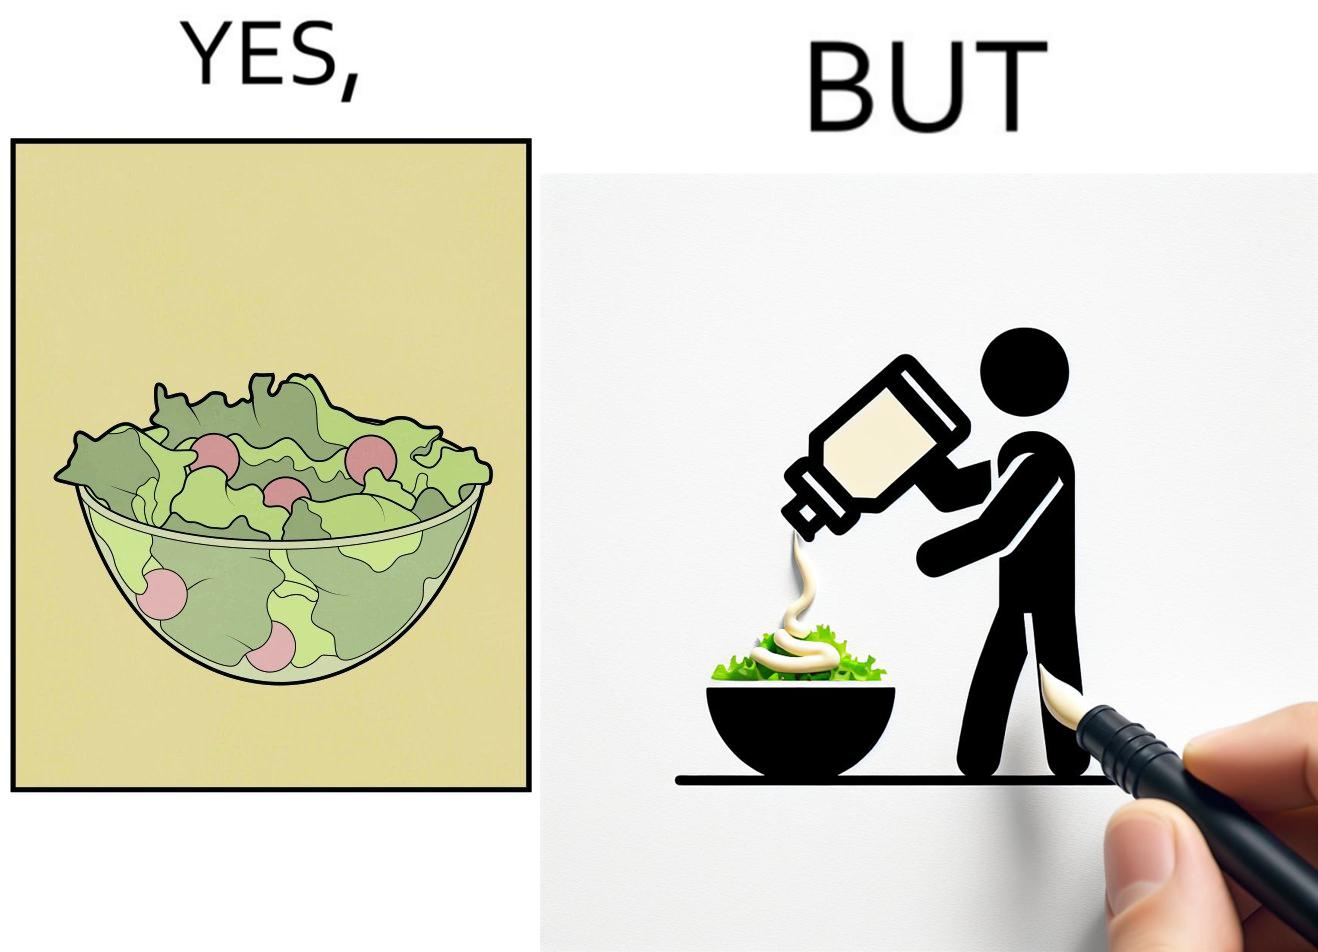Is this image satirical or non-satirical? Yes, this image is satirical. 